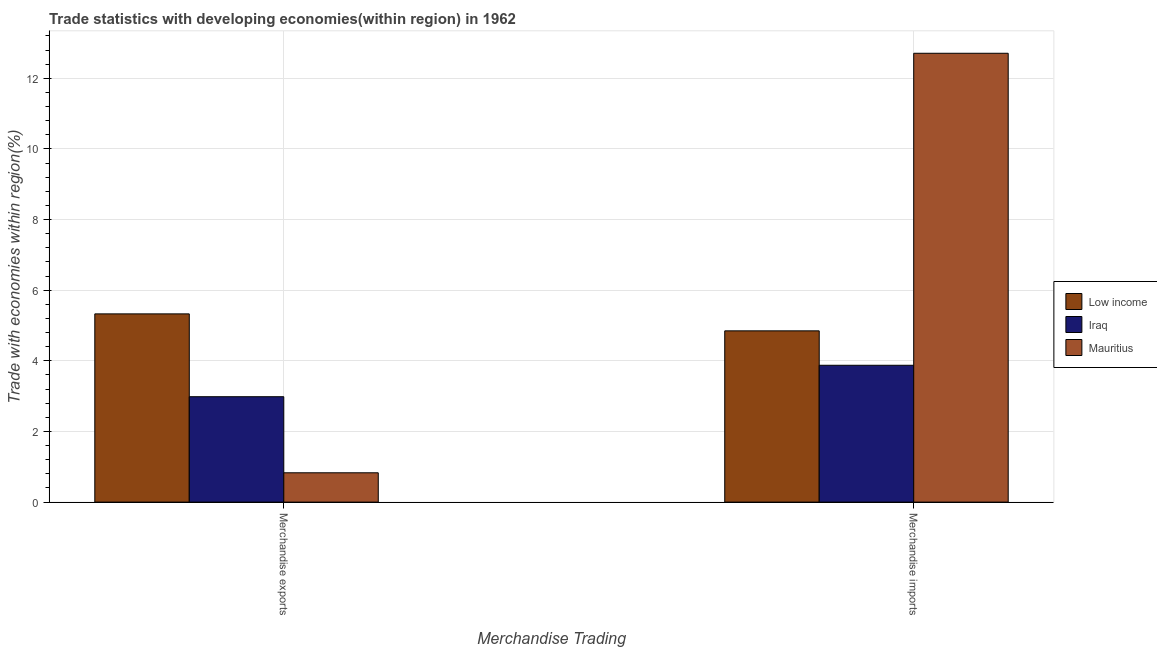How many groups of bars are there?
Make the answer very short. 2. Are the number of bars per tick equal to the number of legend labels?
Offer a very short reply. Yes. What is the merchandise exports in Iraq?
Keep it short and to the point. 2.99. Across all countries, what is the maximum merchandise exports?
Your answer should be compact. 5.33. Across all countries, what is the minimum merchandise imports?
Your response must be concise. 3.88. In which country was the merchandise exports minimum?
Make the answer very short. Mauritius. What is the total merchandise imports in the graph?
Your answer should be very brief. 21.44. What is the difference between the merchandise exports in Low income and that in Iraq?
Offer a terse response. 2.35. What is the difference between the merchandise exports in Mauritius and the merchandise imports in Iraq?
Offer a very short reply. -3.04. What is the average merchandise imports per country?
Provide a short and direct response. 7.15. What is the difference between the merchandise imports and merchandise exports in Mauritius?
Your response must be concise. 11.88. In how many countries, is the merchandise exports greater than 9.2 %?
Offer a terse response. 0. What is the ratio of the merchandise exports in Iraq to that in Mauritius?
Provide a short and direct response. 3.59. In how many countries, is the merchandise imports greater than the average merchandise imports taken over all countries?
Your answer should be compact. 1. What does the 2nd bar from the left in Merchandise exports represents?
Your answer should be compact. Iraq. What does the 2nd bar from the right in Merchandise exports represents?
Give a very brief answer. Iraq. How many bars are there?
Keep it short and to the point. 6. How many countries are there in the graph?
Make the answer very short. 3. Are the values on the major ticks of Y-axis written in scientific E-notation?
Make the answer very short. No. Does the graph contain grids?
Offer a very short reply. Yes. What is the title of the graph?
Give a very brief answer. Trade statistics with developing economies(within region) in 1962. Does "Central African Republic" appear as one of the legend labels in the graph?
Ensure brevity in your answer.  No. What is the label or title of the X-axis?
Make the answer very short. Merchandise Trading. What is the label or title of the Y-axis?
Your answer should be compact. Trade with economies within region(%). What is the Trade with economies within region(%) of Low income in Merchandise exports?
Your answer should be very brief. 5.33. What is the Trade with economies within region(%) of Iraq in Merchandise exports?
Offer a terse response. 2.99. What is the Trade with economies within region(%) in Mauritius in Merchandise exports?
Your response must be concise. 0.83. What is the Trade with economies within region(%) in Low income in Merchandise imports?
Offer a terse response. 4.85. What is the Trade with economies within region(%) in Iraq in Merchandise imports?
Offer a terse response. 3.88. What is the Trade with economies within region(%) in Mauritius in Merchandise imports?
Ensure brevity in your answer.  12.71. Across all Merchandise Trading, what is the maximum Trade with economies within region(%) in Low income?
Give a very brief answer. 5.33. Across all Merchandise Trading, what is the maximum Trade with economies within region(%) of Iraq?
Your answer should be compact. 3.88. Across all Merchandise Trading, what is the maximum Trade with economies within region(%) in Mauritius?
Provide a succinct answer. 12.71. Across all Merchandise Trading, what is the minimum Trade with economies within region(%) in Low income?
Your response must be concise. 4.85. Across all Merchandise Trading, what is the minimum Trade with economies within region(%) of Iraq?
Provide a short and direct response. 2.99. Across all Merchandise Trading, what is the minimum Trade with economies within region(%) in Mauritius?
Your response must be concise. 0.83. What is the total Trade with economies within region(%) in Low income in the graph?
Your answer should be compact. 10.18. What is the total Trade with economies within region(%) of Iraq in the graph?
Provide a succinct answer. 6.86. What is the total Trade with economies within region(%) of Mauritius in the graph?
Offer a terse response. 13.54. What is the difference between the Trade with economies within region(%) of Low income in Merchandise exports and that in Merchandise imports?
Offer a very short reply. 0.48. What is the difference between the Trade with economies within region(%) of Iraq in Merchandise exports and that in Merchandise imports?
Give a very brief answer. -0.89. What is the difference between the Trade with economies within region(%) of Mauritius in Merchandise exports and that in Merchandise imports?
Make the answer very short. -11.88. What is the difference between the Trade with economies within region(%) in Low income in Merchandise exports and the Trade with economies within region(%) in Iraq in Merchandise imports?
Your answer should be very brief. 1.46. What is the difference between the Trade with economies within region(%) of Low income in Merchandise exports and the Trade with economies within region(%) of Mauritius in Merchandise imports?
Your answer should be compact. -7.38. What is the difference between the Trade with economies within region(%) in Iraq in Merchandise exports and the Trade with economies within region(%) in Mauritius in Merchandise imports?
Your answer should be very brief. -9.73. What is the average Trade with economies within region(%) in Low income per Merchandise Trading?
Ensure brevity in your answer.  5.09. What is the average Trade with economies within region(%) in Iraq per Merchandise Trading?
Keep it short and to the point. 3.43. What is the average Trade with economies within region(%) in Mauritius per Merchandise Trading?
Offer a terse response. 6.77. What is the difference between the Trade with economies within region(%) in Low income and Trade with economies within region(%) in Iraq in Merchandise exports?
Your answer should be compact. 2.35. What is the difference between the Trade with economies within region(%) in Low income and Trade with economies within region(%) in Mauritius in Merchandise exports?
Make the answer very short. 4.5. What is the difference between the Trade with economies within region(%) in Iraq and Trade with economies within region(%) in Mauritius in Merchandise exports?
Your answer should be very brief. 2.15. What is the difference between the Trade with economies within region(%) in Low income and Trade with economies within region(%) in Iraq in Merchandise imports?
Make the answer very short. 0.97. What is the difference between the Trade with economies within region(%) of Low income and Trade with economies within region(%) of Mauritius in Merchandise imports?
Keep it short and to the point. -7.86. What is the difference between the Trade with economies within region(%) of Iraq and Trade with economies within region(%) of Mauritius in Merchandise imports?
Offer a terse response. -8.84. What is the ratio of the Trade with economies within region(%) in Low income in Merchandise exports to that in Merchandise imports?
Offer a very short reply. 1.1. What is the ratio of the Trade with economies within region(%) of Iraq in Merchandise exports to that in Merchandise imports?
Your response must be concise. 0.77. What is the ratio of the Trade with economies within region(%) of Mauritius in Merchandise exports to that in Merchandise imports?
Provide a short and direct response. 0.07. What is the difference between the highest and the second highest Trade with economies within region(%) of Low income?
Provide a short and direct response. 0.48. What is the difference between the highest and the second highest Trade with economies within region(%) in Iraq?
Provide a succinct answer. 0.89. What is the difference between the highest and the second highest Trade with economies within region(%) in Mauritius?
Provide a short and direct response. 11.88. What is the difference between the highest and the lowest Trade with economies within region(%) of Low income?
Make the answer very short. 0.48. What is the difference between the highest and the lowest Trade with economies within region(%) in Iraq?
Give a very brief answer. 0.89. What is the difference between the highest and the lowest Trade with economies within region(%) of Mauritius?
Provide a short and direct response. 11.88. 